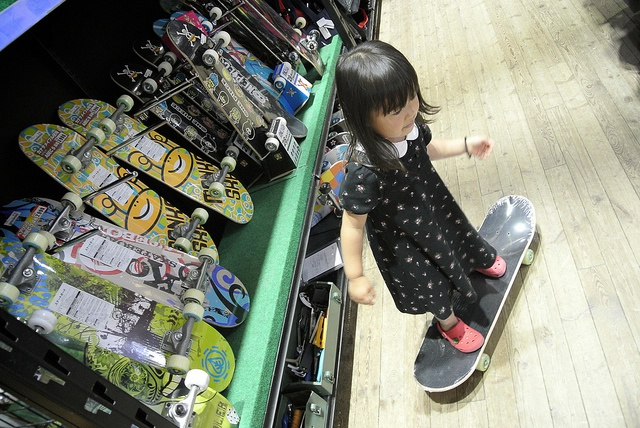Describe the objects in this image and their specific colors. I can see people in darkgreen, black, gray, darkgray, and tan tones, skateboard in darkgreen, gray, darkgray, olive, and lightgray tones, skateboard in darkgreen, darkgray, gray, black, and lightgray tones, skateboard in darkgreen, gray, black, darkgray, and tan tones, and skateboard in darkgreen, black, gray, darkgray, and olive tones in this image. 